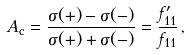Convert formula to latex. <formula><loc_0><loc_0><loc_500><loc_500>A _ { \mathrm c } = \frac { \sigma ( + ) - \sigma ( - ) } { \sigma ( + ) + \sigma ( - ) } = \frac { f ^ { \prime } _ { 1 1 } } { f _ { 1 1 } } \, ,</formula> 